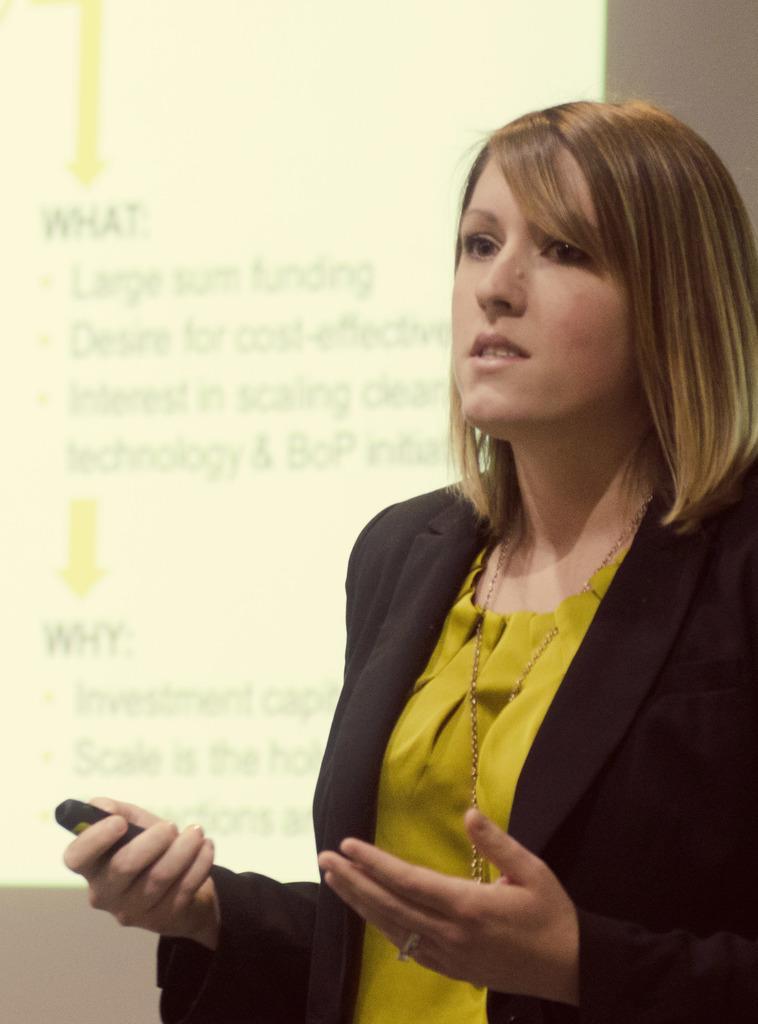In one or two sentences, can you explain what this image depicts? On the right there is a woman holding an electronic gadget, she is wearing a jacket. In the background it might be a projector screen we can see text also. 